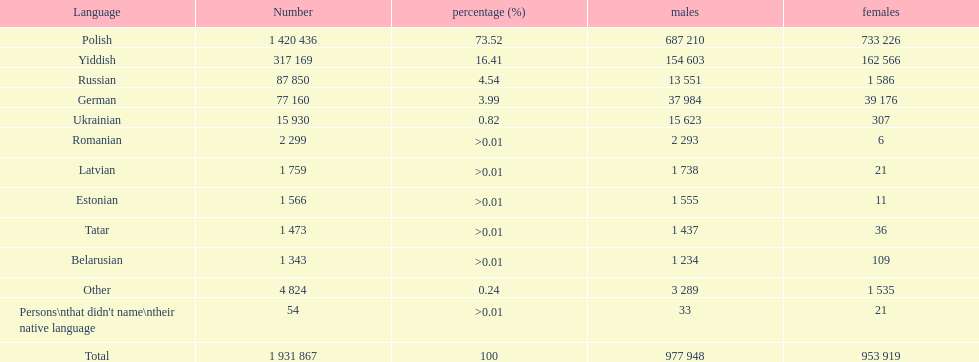When comparing the number of speakers, is german ranked above or below russian? Below. 